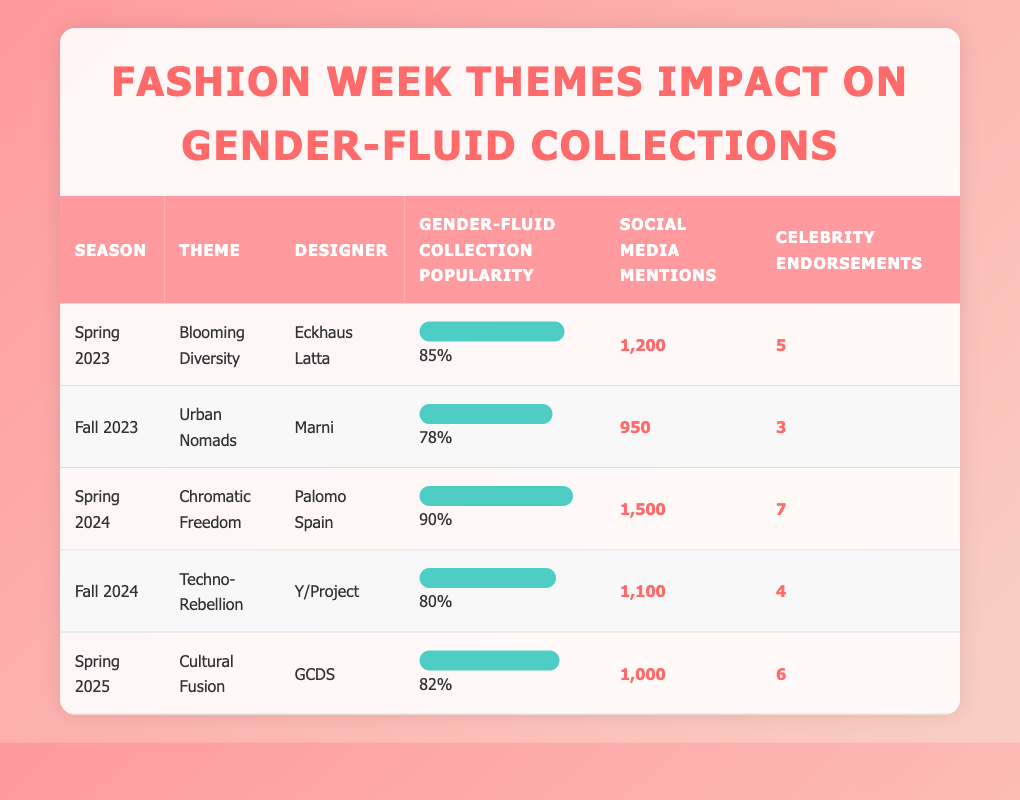What is the Gender-Fluid Collection Popularity of Palomo Spain? The table lists Palomo Spain under the Season "Spring 2024" with a Gender-Fluid Collection Popularity of 90%.
Answer: 90% Which designer received the highest number of Social Media Mentions? By examining the Social Media Mentions column, Palomo Spain has the highest number with 1,500 mentions.
Answer: Palomo Spain What is the average Gender-Fluid Collection Popularity across all designs listed in the table? Adding the Gender-Fluid Collection Popularity values (85 + 78 + 90 + 80 + 82) = 415, and then dividing by 5 (the number of designers) gives the average: 415/5 = 83.
Answer: 83 Is there a designer with more than 5 celebrity endorsements? Checking the Celebrity Endorsements column, Palomo Spain has 7 endorsements which is more than 5, making the statement true.
Answer: Yes Which season had the theme "Techno-Rebellion" and what was its popularity? The theme "Techno-Rebellion" corresponds to the Fall 2024 season, and its Gender-Fluid Collection Popularity is 80%.
Answer: Fall 2024, 80% How many total Celebrity Endorsements were garnered by all designers? Summing the Celebrity Endorsements (5 + 3 + 7 + 4 + 6) gives a total of 25 endorsements across all designers.
Answer: 25 Based on the data, which theme appears to generate the least popularity in gender-fluid collections? Comparing the popularity values, "Urban Nomads" from Fall 2023 has the lowest at 78%, making it the least popular theme.
Answer: Urban Nomads Does the data show that Social Media Mentions correlate with higher Gender-Fluid Collection Popularity? Analyzing the data, Palomo Spain with the highest popularity (90%) also has the highest mentions (1,500), while Marni with the lowest popularity (78%) has fewer mentions (950), suggesting a correlation.
Answer: Yes What is the difference in Gender-Fluid Collection Popularity between "Blooming Diversity" and "Cultural Fusion"? The difference is calculated as 85% (Blooming Diversity) - 82% (Cultural Fusion) = 3%.
Answer: 3% 